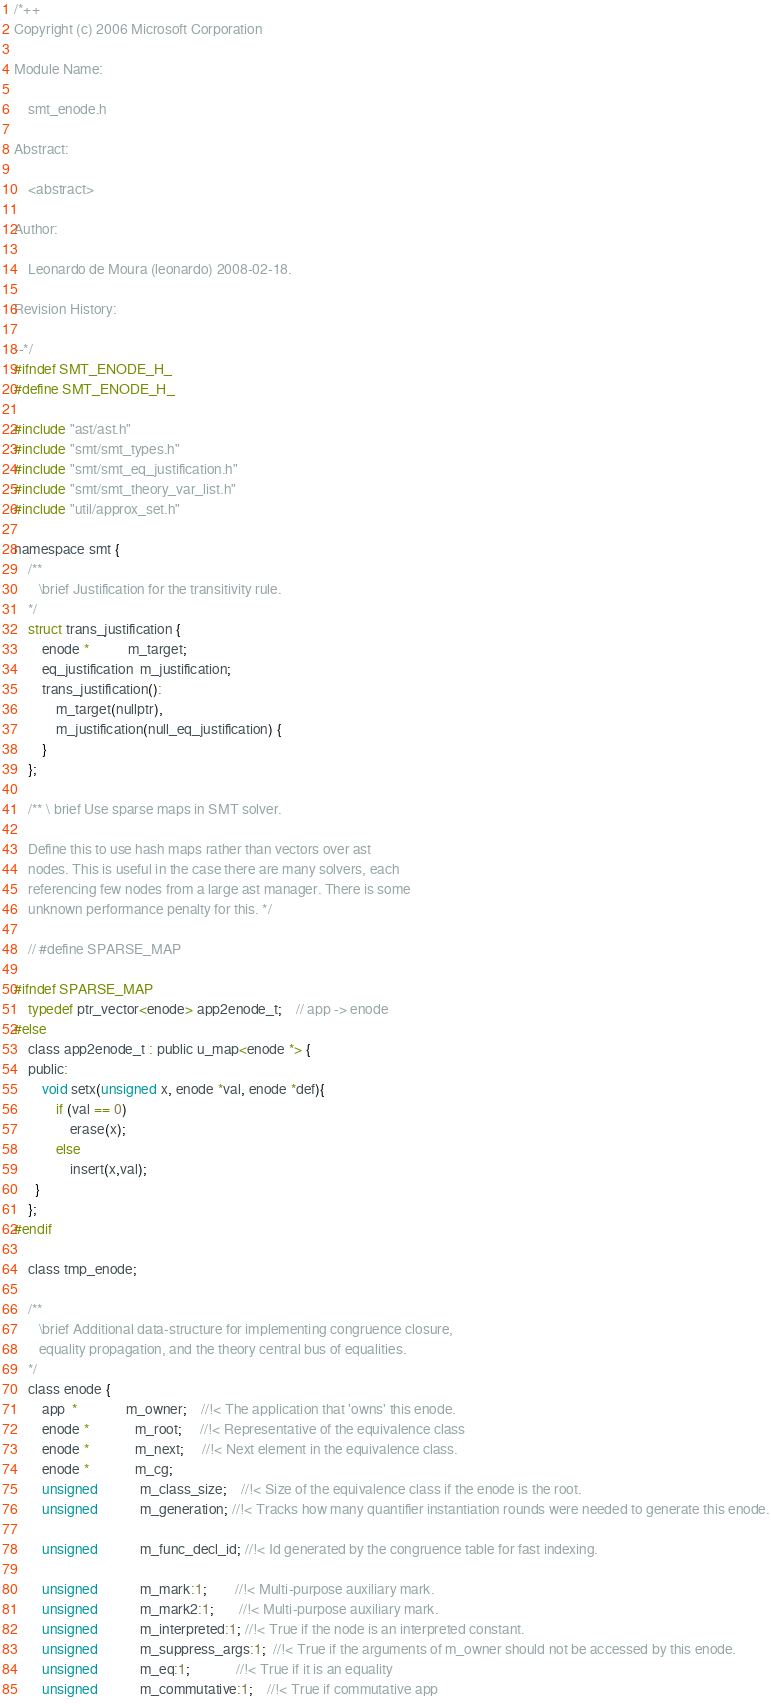Convert code to text. <code><loc_0><loc_0><loc_500><loc_500><_C_>/*++
Copyright (c) 2006 Microsoft Corporation

Module Name:

    smt_enode.h

Abstract:

    <abstract>

Author:

    Leonardo de Moura (leonardo) 2008-02-18.

Revision History:

--*/
#ifndef SMT_ENODE_H_
#define SMT_ENODE_H_

#include "ast/ast.h"
#include "smt/smt_types.h"
#include "smt/smt_eq_justification.h"
#include "smt/smt_theory_var_list.h"
#include "util/approx_set.h"

namespace smt {
    /**
       \brief Justification for the transitivity rule.
    */
    struct trans_justification {
        enode *           m_target;
        eq_justification  m_justification;
        trans_justification():
            m_target(nullptr),
            m_justification(null_eq_justification) {
        }
    };

    /** \ brief Use sparse maps in SMT solver.

    Define this to use hash maps rather than vectors over ast
    nodes. This is useful in the case there are many solvers, each
    referencing few nodes from a large ast manager. There is some
    unknown performance penalty for this. */

    // #define SPARSE_MAP

#ifndef SPARSE_MAP
    typedef ptr_vector<enode> app2enode_t;    // app -> enode
#else
    class app2enode_t : public u_map<enode *> {
    public:
        void setx(unsigned x, enode *val, enode *def){
            if (val == 0)
                erase(x);
            else
                insert(x,val);
      }
    };
#endif

    class tmp_enode;

    /**
       \brief Additional data-structure for implementing congruence closure,
       equality propagation, and the theory central bus of equalities.
    */
    class enode {
        app  *              m_owner;    //!< The application that 'owns' this enode.
        enode *             m_root;     //!< Representative of the equivalence class
        enode *             m_next;     //!< Next element in the equivalence class.
        enode *             m_cg;       
        unsigned            m_class_size;    //!< Size of the equivalence class if the enode is the root.
        unsigned            m_generation; //!< Tracks how many quantifier instantiation rounds were needed to generate this enode.

        unsigned            m_func_decl_id; //!< Id generated by the congruence table for fast indexing.

        unsigned            m_mark:1;        //!< Multi-purpose auxiliary mark. 
        unsigned            m_mark2:1;       //!< Multi-purpose auxiliary mark. 
        unsigned            m_interpreted:1; //!< True if the node is an interpreted constant.
        unsigned            m_suppress_args:1;  //!< True if the arguments of m_owner should not be accessed by this enode.
        unsigned            m_eq:1;             //!< True if it is an equality
        unsigned            m_commutative:1;    //!< True if commutative app</code> 